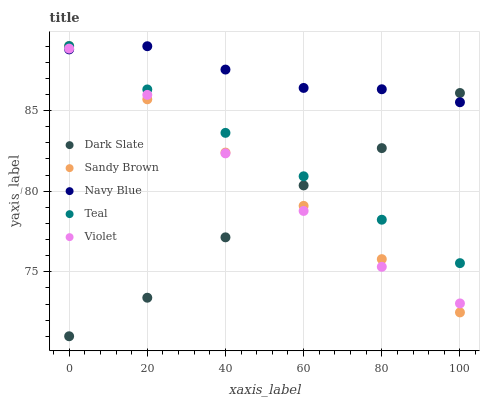Does Dark Slate have the minimum area under the curve?
Answer yes or no. Yes. Does Navy Blue have the maximum area under the curve?
Answer yes or no. Yes. Does Violet have the minimum area under the curve?
Answer yes or no. No. Does Violet have the maximum area under the curve?
Answer yes or no. No. Is Sandy Brown the smoothest?
Answer yes or no. Yes. Is Dark Slate the roughest?
Answer yes or no. Yes. Is Violet the smoothest?
Answer yes or no. No. Is Violet the roughest?
Answer yes or no. No. Does Dark Slate have the lowest value?
Answer yes or no. Yes. Does Violet have the lowest value?
Answer yes or no. No. Does Teal have the highest value?
Answer yes or no. Yes. Does Violet have the highest value?
Answer yes or no. No. Is Violet less than Teal?
Answer yes or no. Yes. Is Teal greater than Violet?
Answer yes or no. Yes. Does Dark Slate intersect Violet?
Answer yes or no. Yes. Is Dark Slate less than Violet?
Answer yes or no. No. Is Dark Slate greater than Violet?
Answer yes or no. No. Does Violet intersect Teal?
Answer yes or no. No. 